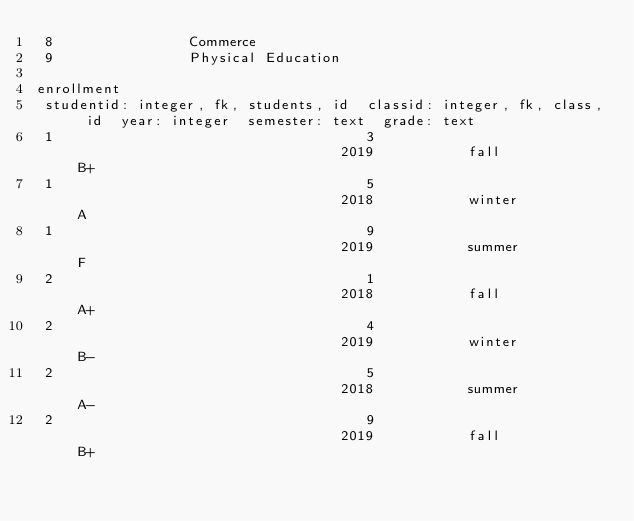Convert code to text. <code><loc_0><loc_0><loc_500><loc_500><_SQL_> 8                Commerce           
 9                Physical Education 

enrollment
 studentid: integer, fk, students, id  classid: integer, fk, class, id  year: integer  semester: text  grade: text 
 1                                     3                                2019           fall            B+          
 1                                     5                                2018           winter          A           
 1                                     9                                2019           summer          F           
 2                                     1                                2018           fall            A+          
 2                                     4                                2019           winter          B-          
 2                                     5                                2018           summer          A-          
 2                                     9                                2019           fall            B+          
</code> 